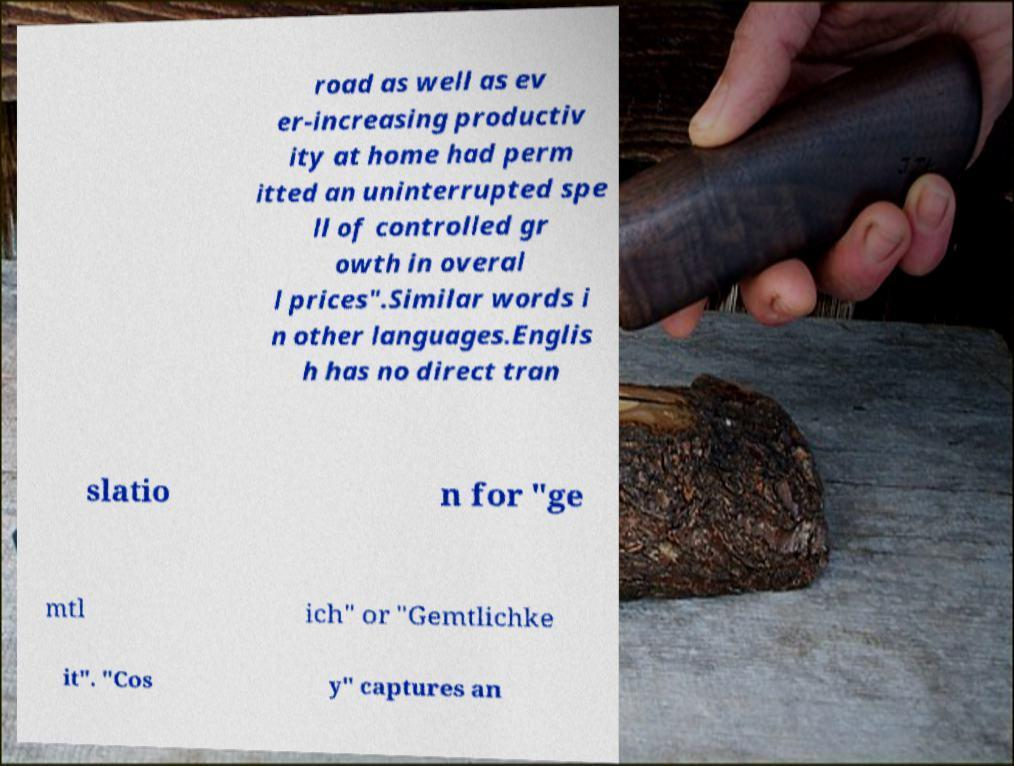Could you extract and type out the text from this image? road as well as ev er-increasing productiv ity at home had perm itted an uninterrupted spe ll of controlled gr owth in overal l prices".Similar words i n other languages.Englis h has no direct tran slatio n for "ge mtl ich" or "Gemtlichke it". "Cos y" captures an 